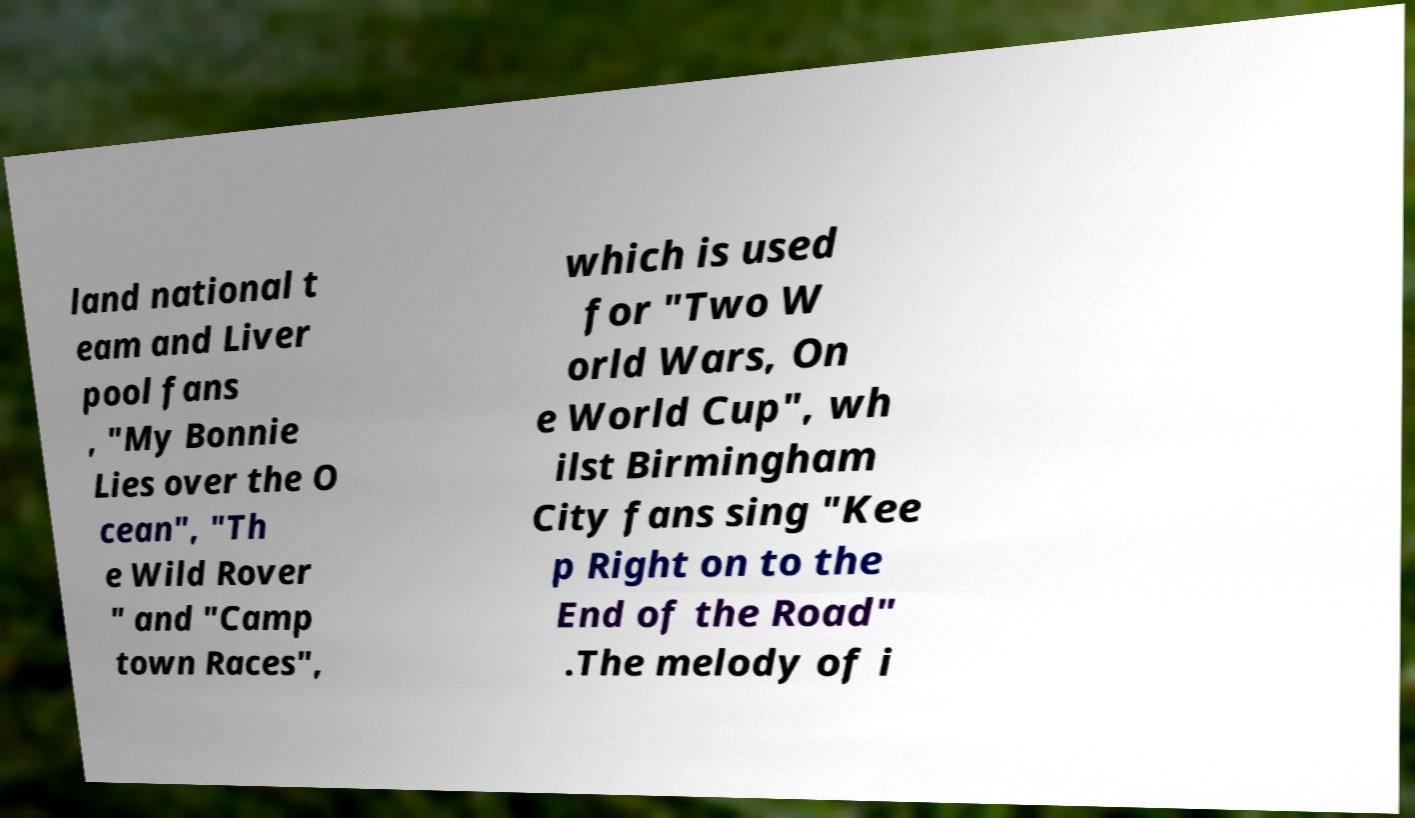What messages or text are displayed in this image? I need them in a readable, typed format. land national t eam and Liver pool fans , "My Bonnie Lies over the O cean", "Th e Wild Rover " and "Camp town Races", which is used for "Two W orld Wars, On e World Cup", wh ilst Birmingham City fans sing "Kee p Right on to the End of the Road" .The melody of i 